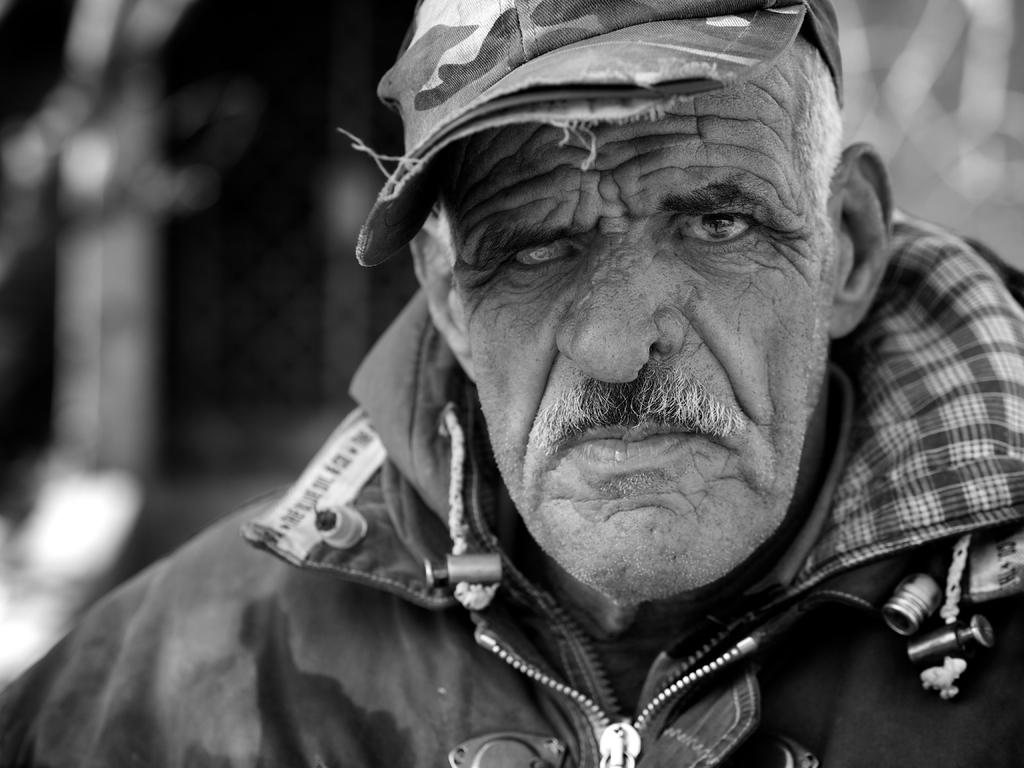What is the main subject of the picture? The main subject of the picture is a man. What is the man wearing on his head? The man is wearing a cap. What type of clothing is the man wearing on his upper body? The man is wearing a jacket. What is the color scheme of the picture? The picture is black and white in color. How would you describe the background of the picture? The background of the picture is blurred. What type of sleet can be seen falling in the background of the image? There is no sleet present in the image, as it is a black and white picture of a man wearing a cap and jacket. What nation does the man in the image represent? The image does not provide any information about the man's nationality or the nation he represents. 